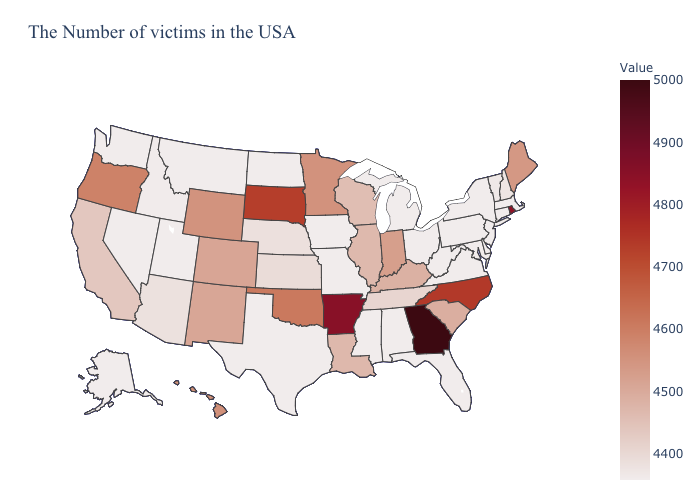Among the states that border Pennsylvania , which have the highest value?
Answer briefly. New York, New Jersey, Delaware, Maryland, West Virginia, Ohio. Among the states that border Delaware , which have the highest value?
Answer briefly. New Jersey, Maryland, Pennsylvania. Among the states that border New Hampshire , which have the highest value?
Give a very brief answer. Maine. Among the states that border Kansas , which have the lowest value?
Be succinct. Missouri. Does Georgia have the lowest value in the South?
Be succinct. No. Among the states that border Mississippi , which have the lowest value?
Answer briefly. Alabama. 